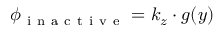<formula> <loc_0><loc_0><loc_500><loc_500>\phi _ { i n a c t i v e } = k _ { z } \cdot g ( y )</formula> 